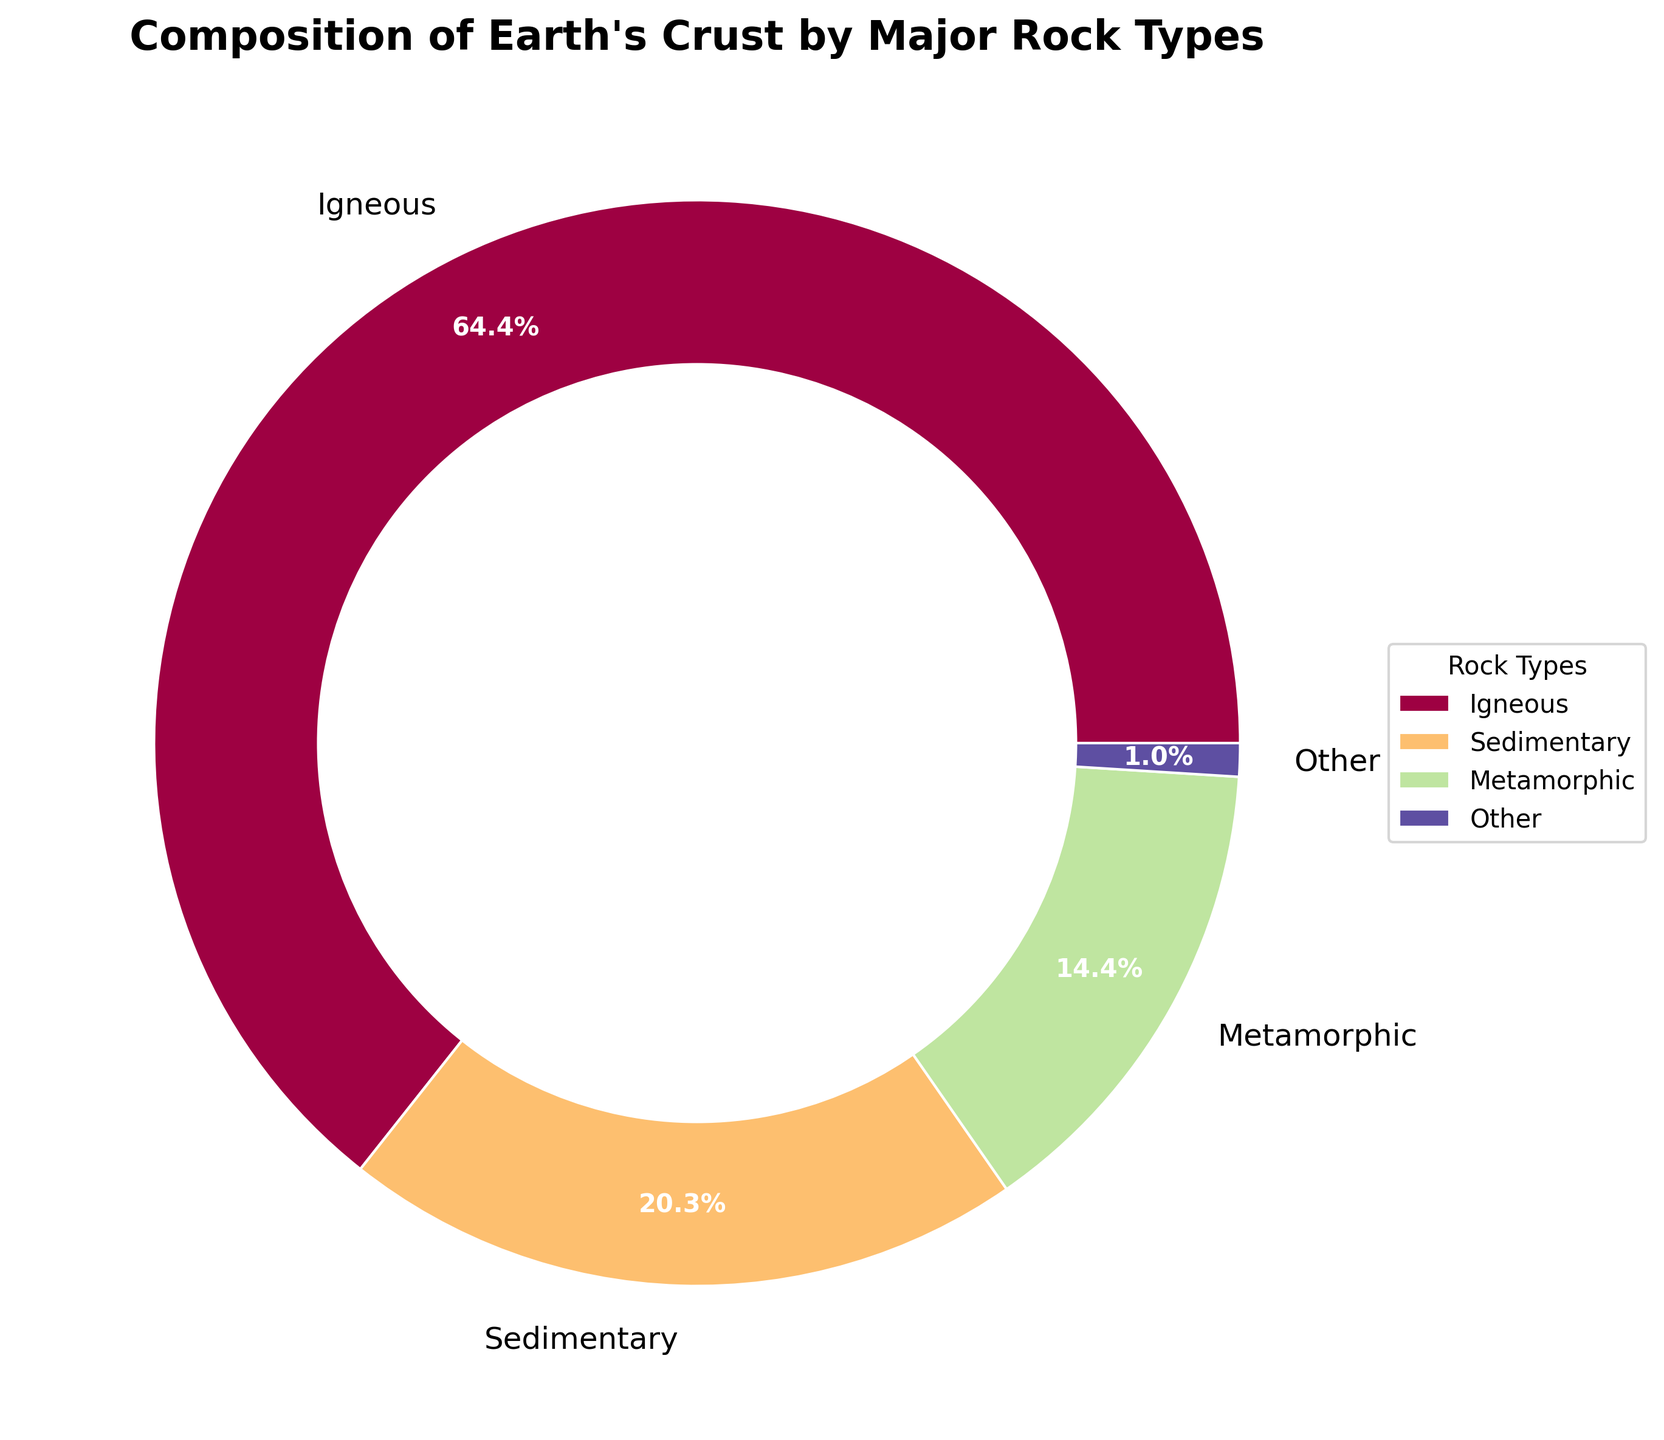What's the largest rock type by percentage in Earth's crust? The largest segment of the pie chart represents igneous rocks at 65.0% of the Earth's crust.
Answer: Igneous What is the combined percentage of sedimentary and metamorphic rocks? The chart shows sedimentary rocks at 20.5% and metamorphic rocks at 14.5%. Summing these gives 20.5% + 14.5% = 35.0%.
Answer: 35.0% Which rock type has the smallest percentage and how much is it? The chart categorizes rock types under "Other" if they are less than 1.0%, combining volcanic glass, carbonatites, evaporites, and hydrothermal deposits. Among them, evaporites and hydrothermal deposits are each at 0.1%, which are the smallest percentages individually.
Answer: Evaporites and Hydrothermal Deposits, 0.1% Is "Other" a significant portion of the Earth's crust? The "Other" category is made up of rock types each constituting less than 1.0% of the Earth's crust. Adding these up: volcanic glass (0.5%), carbonatites (0.3%), evaporites (0.1%), and hydrothermal deposits (0.1%), gives a total of 1.0%. Thus, it forms a small portion of the crust.
Answer: No, it forms a small portion How does the percentage of igneous rocks compare to the sum of sedimentary and metamorphic rocks? Igneous rocks constitute 65.0% while the combined percentage of sedimentary and metamorphic rocks is 35.0%. By comparing, igneous rocks are nearly twice the sum of sedimentary and metamorphic rocks. 65.0% is significantly larger than 35.0%.
Answer: Igneous rocks are nearly double What color represents metamorphic rocks in the chart? The pie chart uses distinct colors for different rock types. To identify, locate the metamorphic rock segment labeled at 14.5% and observe the color assigned to this segment.
Answer: Color corresponding to the metamorphic segment Does the pie chart use a donut style, and if so, how is it created? The pie chart has a central circle that gives it a donut appearance. This circle in the middle makes it not appear as a traditional pie chart. The central space is filled with a circle of white color, creating the donut effect.
Answer: Yes, with a central circle 